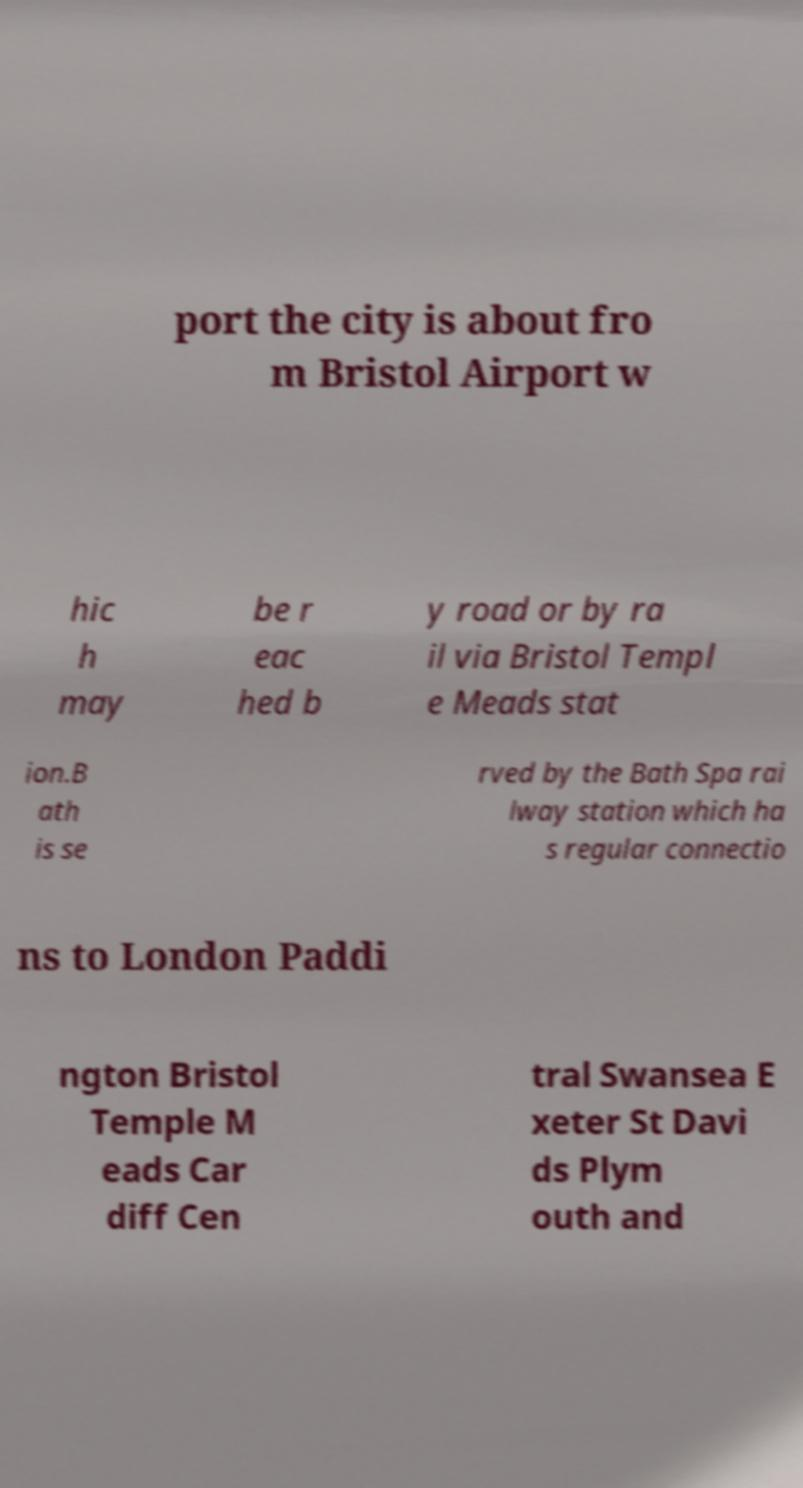Can you read and provide the text displayed in the image?This photo seems to have some interesting text. Can you extract and type it out for me? port the city is about fro m Bristol Airport w hic h may be r eac hed b y road or by ra il via Bristol Templ e Meads stat ion.B ath is se rved by the Bath Spa rai lway station which ha s regular connectio ns to London Paddi ngton Bristol Temple M eads Car diff Cen tral Swansea E xeter St Davi ds Plym outh and 